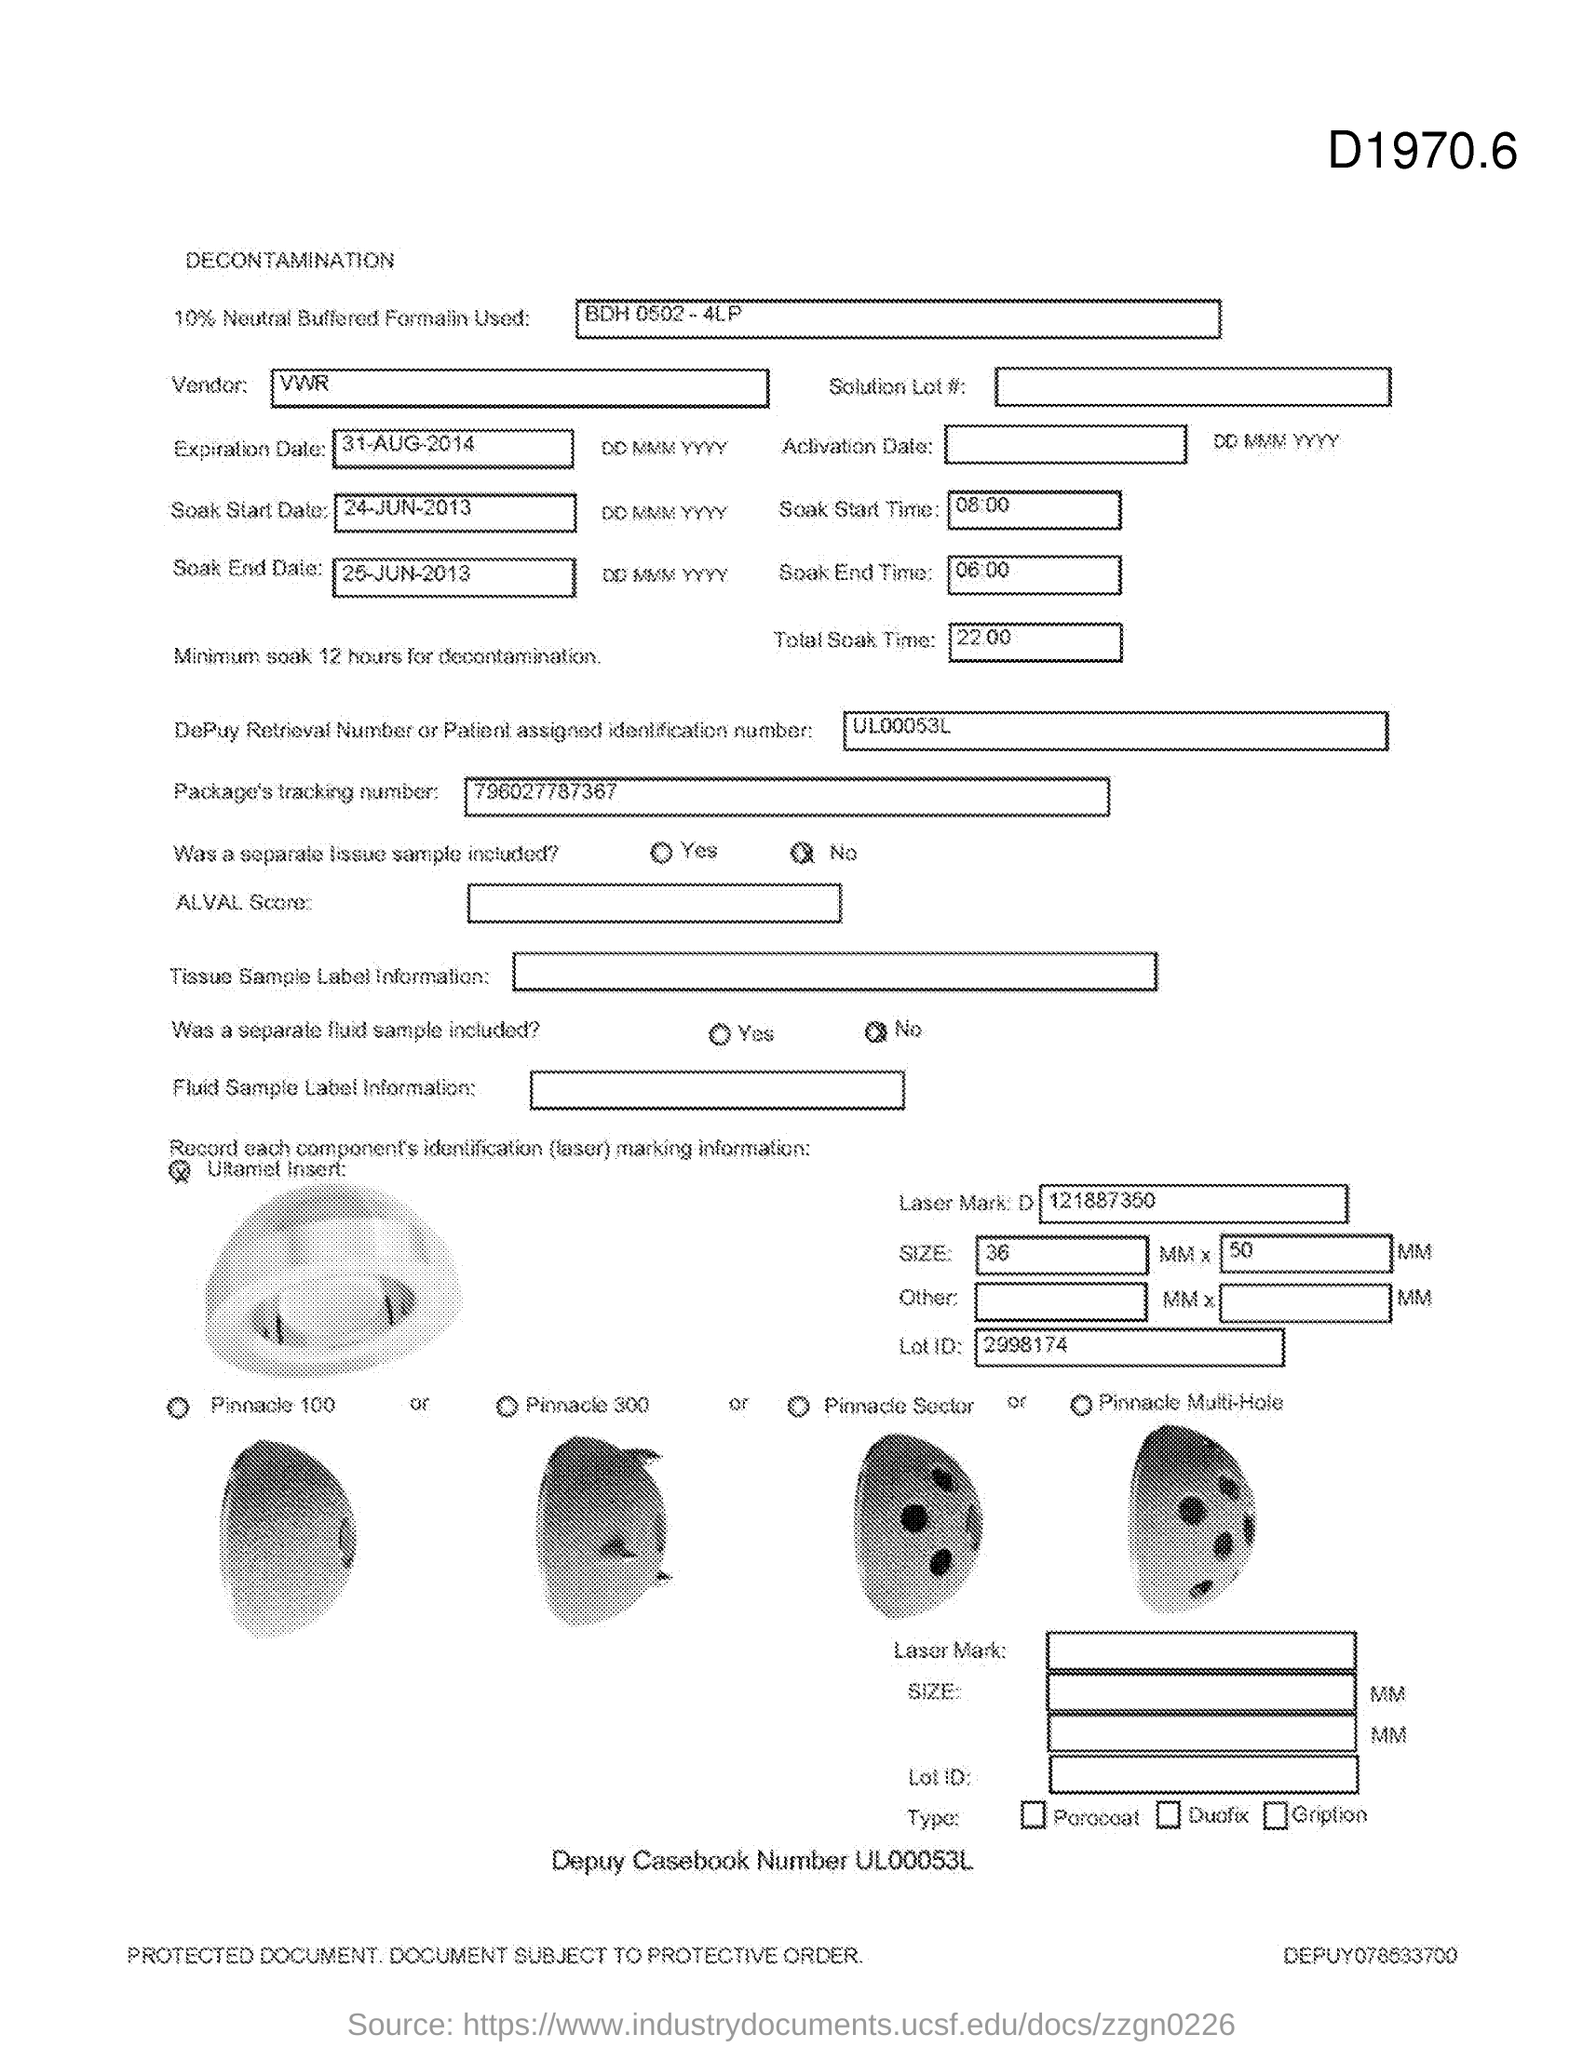What is the Total Soak Time?
Your answer should be compact. 22:00. What is the Soak End Time?
Your answer should be compact. 06:00. What is the Soak Start Time?
Offer a very short reply. 08:00. 